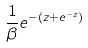<formula> <loc_0><loc_0><loc_500><loc_500>\frac { 1 } { \beta } e ^ { - ( z + e ^ { - z } ) }</formula> 